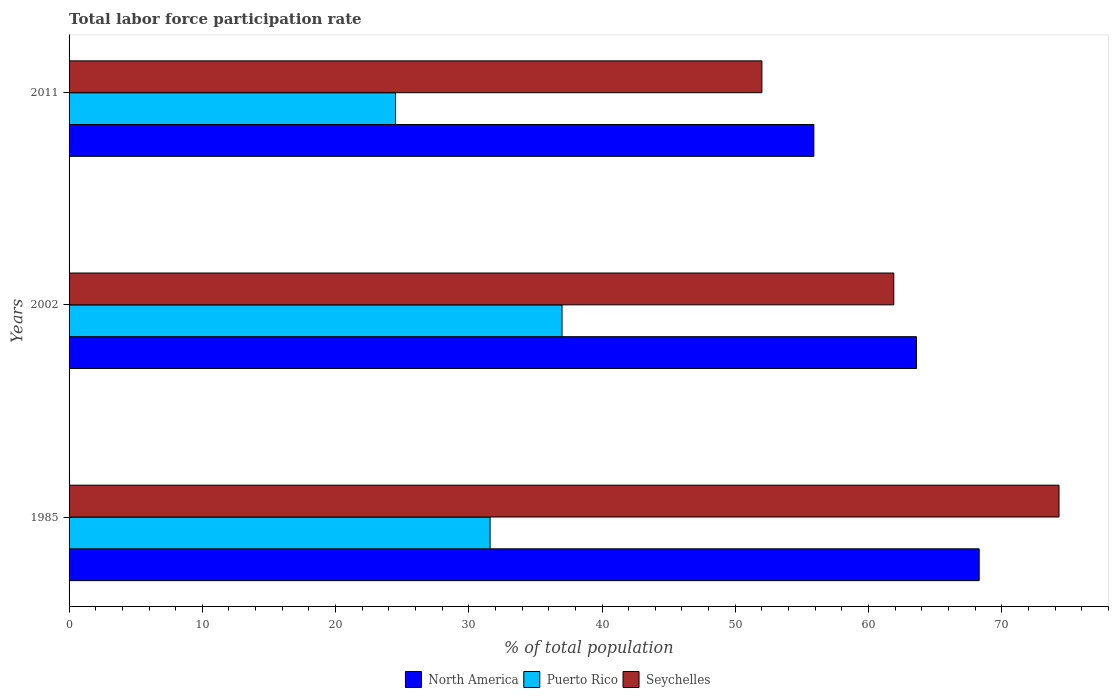How many different coloured bars are there?
Ensure brevity in your answer.  3. How many groups of bars are there?
Offer a terse response. 3. How many bars are there on the 2nd tick from the bottom?
Your answer should be compact. 3. What is the total labor force participation rate in Seychelles in 1985?
Your response must be concise. 74.3. Across all years, what is the maximum total labor force participation rate in Seychelles?
Give a very brief answer. 74.3. In which year was the total labor force participation rate in Puerto Rico maximum?
Provide a succinct answer. 2002. In which year was the total labor force participation rate in Seychelles minimum?
Keep it short and to the point. 2011. What is the total total labor force participation rate in North America in the graph?
Ensure brevity in your answer.  187.82. What is the difference between the total labor force participation rate in Puerto Rico in 2002 and that in 2011?
Offer a very short reply. 12.5. What is the average total labor force participation rate in Puerto Rico per year?
Make the answer very short. 31.03. In the year 1985, what is the difference between the total labor force participation rate in Puerto Rico and total labor force participation rate in Seychelles?
Your answer should be compact. -42.7. What is the ratio of the total labor force participation rate in Puerto Rico in 2002 to that in 2011?
Your response must be concise. 1.51. Is the total labor force participation rate in North America in 1985 less than that in 2011?
Provide a short and direct response. No. Is the difference between the total labor force participation rate in Puerto Rico in 1985 and 2002 greater than the difference between the total labor force participation rate in Seychelles in 1985 and 2002?
Provide a succinct answer. No. What is the difference between the highest and the second highest total labor force participation rate in North America?
Keep it short and to the point. 4.71. What is the difference between the highest and the lowest total labor force participation rate in Seychelles?
Your answer should be very brief. 22.3. Is the sum of the total labor force participation rate in Puerto Rico in 1985 and 2011 greater than the maximum total labor force participation rate in North America across all years?
Give a very brief answer. No. What does the 1st bar from the top in 2011 represents?
Ensure brevity in your answer.  Seychelles. How many bars are there?
Ensure brevity in your answer.  9. Are all the bars in the graph horizontal?
Ensure brevity in your answer.  Yes. How many years are there in the graph?
Ensure brevity in your answer.  3. Are the values on the major ticks of X-axis written in scientific E-notation?
Make the answer very short. No. Does the graph contain any zero values?
Give a very brief answer. No. What is the title of the graph?
Provide a succinct answer. Total labor force participation rate. What is the label or title of the X-axis?
Offer a very short reply. % of total population. What is the label or title of the Y-axis?
Your answer should be compact. Years. What is the % of total population in North America in 1985?
Your response must be concise. 68.31. What is the % of total population in Puerto Rico in 1985?
Ensure brevity in your answer.  31.6. What is the % of total population in Seychelles in 1985?
Provide a succinct answer. 74.3. What is the % of total population in North America in 2002?
Ensure brevity in your answer.  63.6. What is the % of total population of Puerto Rico in 2002?
Your answer should be compact. 37. What is the % of total population of Seychelles in 2002?
Provide a short and direct response. 61.9. What is the % of total population in North America in 2011?
Make the answer very short. 55.9. What is the % of total population in Puerto Rico in 2011?
Your answer should be very brief. 24.5. Across all years, what is the maximum % of total population of North America?
Give a very brief answer. 68.31. Across all years, what is the maximum % of total population in Seychelles?
Ensure brevity in your answer.  74.3. Across all years, what is the minimum % of total population in North America?
Provide a succinct answer. 55.9. What is the total % of total population in North America in the graph?
Your answer should be very brief. 187.82. What is the total % of total population of Puerto Rico in the graph?
Give a very brief answer. 93.1. What is the total % of total population in Seychelles in the graph?
Give a very brief answer. 188.2. What is the difference between the % of total population of North America in 1985 and that in 2002?
Provide a short and direct response. 4.71. What is the difference between the % of total population in Puerto Rico in 1985 and that in 2002?
Provide a short and direct response. -5.4. What is the difference between the % of total population of Seychelles in 1985 and that in 2002?
Provide a succinct answer. 12.4. What is the difference between the % of total population in North America in 1985 and that in 2011?
Provide a short and direct response. 12.41. What is the difference between the % of total population in Puerto Rico in 1985 and that in 2011?
Make the answer very short. 7.1. What is the difference between the % of total population in Seychelles in 1985 and that in 2011?
Make the answer very short. 22.3. What is the difference between the % of total population of North America in 2002 and that in 2011?
Keep it short and to the point. 7.7. What is the difference between the % of total population in Puerto Rico in 2002 and that in 2011?
Provide a short and direct response. 12.5. What is the difference between the % of total population in Seychelles in 2002 and that in 2011?
Provide a short and direct response. 9.9. What is the difference between the % of total population of North America in 1985 and the % of total population of Puerto Rico in 2002?
Your response must be concise. 31.31. What is the difference between the % of total population in North America in 1985 and the % of total population in Seychelles in 2002?
Keep it short and to the point. 6.41. What is the difference between the % of total population in Puerto Rico in 1985 and the % of total population in Seychelles in 2002?
Provide a short and direct response. -30.3. What is the difference between the % of total population in North America in 1985 and the % of total population in Puerto Rico in 2011?
Provide a short and direct response. 43.81. What is the difference between the % of total population in North America in 1985 and the % of total population in Seychelles in 2011?
Your answer should be very brief. 16.31. What is the difference between the % of total population in Puerto Rico in 1985 and the % of total population in Seychelles in 2011?
Offer a terse response. -20.4. What is the difference between the % of total population in North America in 2002 and the % of total population in Puerto Rico in 2011?
Offer a terse response. 39.1. What is the difference between the % of total population of North America in 2002 and the % of total population of Seychelles in 2011?
Make the answer very short. 11.6. What is the average % of total population of North America per year?
Your answer should be compact. 62.61. What is the average % of total population of Puerto Rico per year?
Provide a succinct answer. 31.03. What is the average % of total population of Seychelles per year?
Offer a very short reply. 62.73. In the year 1985, what is the difference between the % of total population of North America and % of total population of Puerto Rico?
Offer a terse response. 36.71. In the year 1985, what is the difference between the % of total population in North America and % of total population in Seychelles?
Your answer should be very brief. -5.99. In the year 1985, what is the difference between the % of total population of Puerto Rico and % of total population of Seychelles?
Provide a short and direct response. -42.7. In the year 2002, what is the difference between the % of total population of North America and % of total population of Puerto Rico?
Offer a terse response. 26.6. In the year 2002, what is the difference between the % of total population in North America and % of total population in Seychelles?
Give a very brief answer. 1.7. In the year 2002, what is the difference between the % of total population of Puerto Rico and % of total population of Seychelles?
Provide a short and direct response. -24.9. In the year 2011, what is the difference between the % of total population in North America and % of total population in Puerto Rico?
Provide a short and direct response. 31.4. In the year 2011, what is the difference between the % of total population of North America and % of total population of Seychelles?
Your answer should be compact. 3.9. In the year 2011, what is the difference between the % of total population of Puerto Rico and % of total population of Seychelles?
Provide a short and direct response. -27.5. What is the ratio of the % of total population in North America in 1985 to that in 2002?
Offer a terse response. 1.07. What is the ratio of the % of total population in Puerto Rico in 1985 to that in 2002?
Offer a very short reply. 0.85. What is the ratio of the % of total population in Seychelles in 1985 to that in 2002?
Your answer should be compact. 1.2. What is the ratio of the % of total population of North America in 1985 to that in 2011?
Your answer should be compact. 1.22. What is the ratio of the % of total population of Puerto Rico in 1985 to that in 2011?
Your answer should be very brief. 1.29. What is the ratio of the % of total population of Seychelles in 1985 to that in 2011?
Provide a succinct answer. 1.43. What is the ratio of the % of total population in North America in 2002 to that in 2011?
Provide a succinct answer. 1.14. What is the ratio of the % of total population of Puerto Rico in 2002 to that in 2011?
Your answer should be very brief. 1.51. What is the ratio of the % of total population in Seychelles in 2002 to that in 2011?
Give a very brief answer. 1.19. What is the difference between the highest and the second highest % of total population in North America?
Provide a short and direct response. 4.71. What is the difference between the highest and the lowest % of total population of North America?
Keep it short and to the point. 12.41. What is the difference between the highest and the lowest % of total population of Seychelles?
Offer a very short reply. 22.3. 